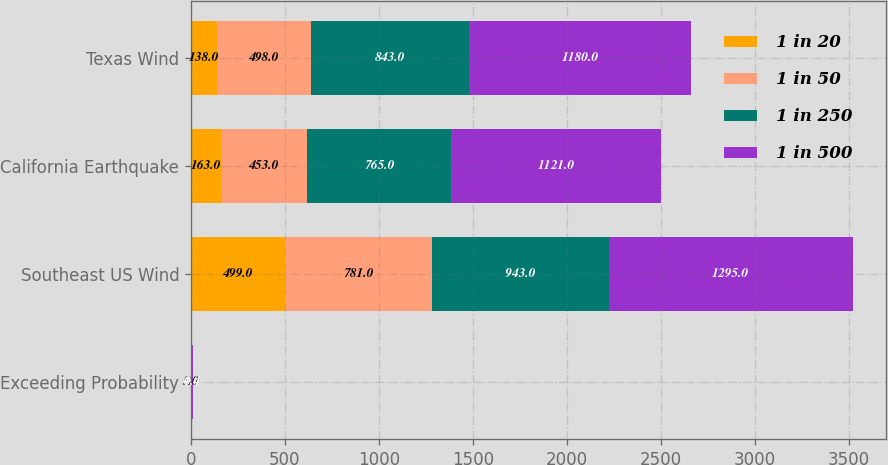<chart> <loc_0><loc_0><loc_500><loc_500><stacked_bar_chart><ecel><fcel>Exceeding Probability<fcel>Southeast US Wind<fcel>California Earthquake<fcel>Texas Wind<nl><fcel>1 in 20<fcel>5<fcel>499<fcel>163<fcel>138<nl><fcel>1 in 50<fcel>2<fcel>781<fcel>453<fcel>498<nl><fcel>1 in 250<fcel>1<fcel>943<fcel>765<fcel>843<nl><fcel>1 in 500<fcel>0.4<fcel>1295<fcel>1121<fcel>1180<nl></chart> 